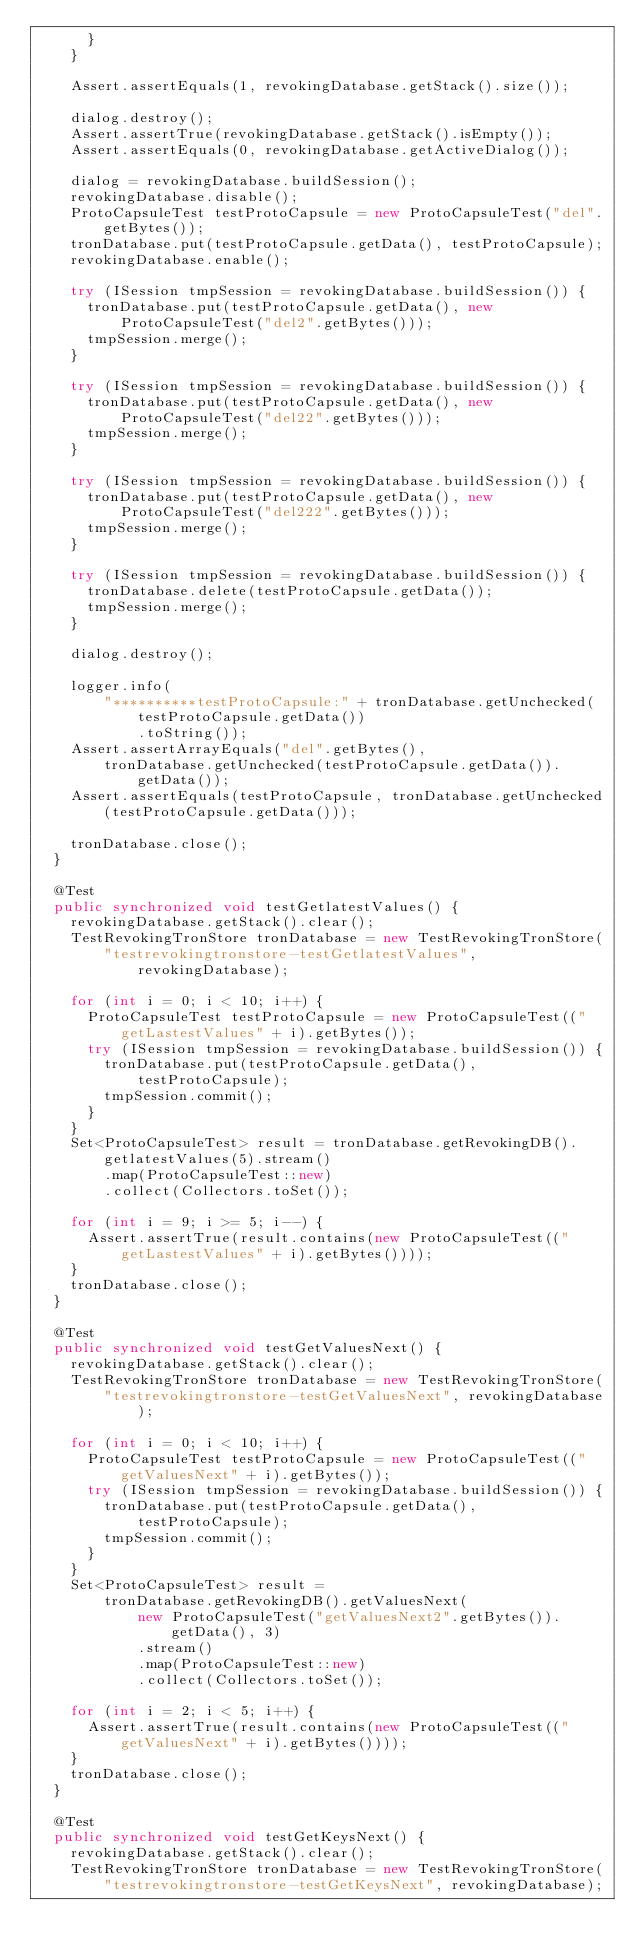Convert code to text. <code><loc_0><loc_0><loc_500><loc_500><_Java_>      }
    }

    Assert.assertEquals(1, revokingDatabase.getStack().size());

    dialog.destroy();
    Assert.assertTrue(revokingDatabase.getStack().isEmpty());
    Assert.assertEquals(0, revokingDatabase.getActiveDialog());

    dialog = revokingDatabase.buildSession();
    revokingDatabase.disable();
    ProtoCapsuleTest testProtoCapsule = new ProtoCapsuleTest("del".getBytes());
    tronDatabase.put(testProtoCapsule.getData(), testProtoCapsule);
    revokingDatabase.enable();

    try (ISession tmpSession = revokingDatabase.buildSession()) {
      tronDatabase.put(testProtoCapsule.getData(), new ProtoCapsuleTest("del2".getBytes()));
      tmpSession.merge();
    }

    try (ISession tmpSession = revokingDatabase.buildSession()) {
      tronDatabase.put(testProtoCapsule.getData(), new ProtoCapsuleTest("del22".getBytes()));
      tmpSession.merge();
    }

    try (ISession tmpSession = revokingDatabase.buildSession()) {
      tronDatabase.put(testProtoCapsule.getData(), new ProtoCapsuleTest("del222".getBytes()));
      tmpSession.merge();
    }

    try (ISession tmpSession = revokingDatabase.buildSession()) {
      tronDatabase.delete(testProtoCapsule.getData());
      tmpSession.merge();
    }

    dialog.destroy();

    logger.info(
        "**********testProtoCapsule:" + tronDatabase.getUnchecked(testProtoCapsule.getData())
            .toString());
    Assert.assertArrayEquals("del".getBytes(),
        tronDatabase.getUnchecked(testProtoCapsule.getData()).getData());
    Assert.assertEquals(testProtoCapsule, tronDatabase.getUnchecked(testProtoCapsule.getData()));

    tronDatabase.close();
  }

  @Test
  public synchronized void testGetlatestValues() {
    revokingDatabase.getStack().clear();
    TestRevokingTronStore tronDatabase = new TestRevokingTronStore(
        "testrevokingtronstore-testGetlatestValues", revokingDatabase);

    for (int i = 0; i < 10; i++) {
      ProtoCapsuleTest testProtoCapsule = new ProtoCapsuleTest(("getLastestValues" + i).getBytes());
      try (ISession tmpSession = revokingDatabase.buildSession()) {
        tronDatabase.put(testProtoCapsule.getData(), testProtoCapsule);
        tmpSession.commit();
      }
    }
    Set<ProtoCapsuleTest> result = tronDatabase.getRevokingDB().getlatestValues(5).stream()
        .map(ProtoCapsuleTest::new)
        .collect(Collectors.toSet());

    for (int i = 9; i >= 5; i--) {
      Assert.assertTrue(result.contains(new ProtoCapsuleTest(("getLastestValues" + i).getBytes())));
    }
    tronDatabase.close();
  }

  @Test
  public synchronized void testGetValuesNext() {
    revokingDatabase.getStack().clear();
    TestRevokingTronStore tronDatabase = new TestRevokingTronStore(
        "testrevokingtronstore-testGetValuesNext", revokingDatabase);

    for (int i = 0; i < 10; i++) {
      ProtoCapsuleTest testProtoCapsule = new ProtoCapsuleTest(("getValuesNext" + i).getBytes());
      try (ISession tmpSession = revokingDatabase.buildSession()) {
        tronDatabase.put(testProtoCapsule.getData(), testProtoCapsule);
        tmpSession.commit();
      }
    }
    Set<ProtoCapsuleTest> result =
        tronDatabase.getRevokingDB().getValuesNext(
            new ProtoCapsuleTest("getValuesNext2".getBytes()).getData(), 3)
            .stream()
            .map(ProtoCapsuleTest::new)
            .collect(Collectors.toSet());

    for (int i = 2; i < 5; i++) {
      Assert.assertTrue(result.contains(new ProtoCapsuleTest(("getValuesNext" + i).getBytes())));
    }
    tronDatabase.close();
  }

  @Test
  public synchronized void testGetKeysNext() {
    revokingDatabase.getStack().clear();
    TestRevokingTronStore tronDatabase = new TestRevokingTronStore(
        "testrevokingtronstore-testGetKeysNext", revokingDatabase);
</code> 